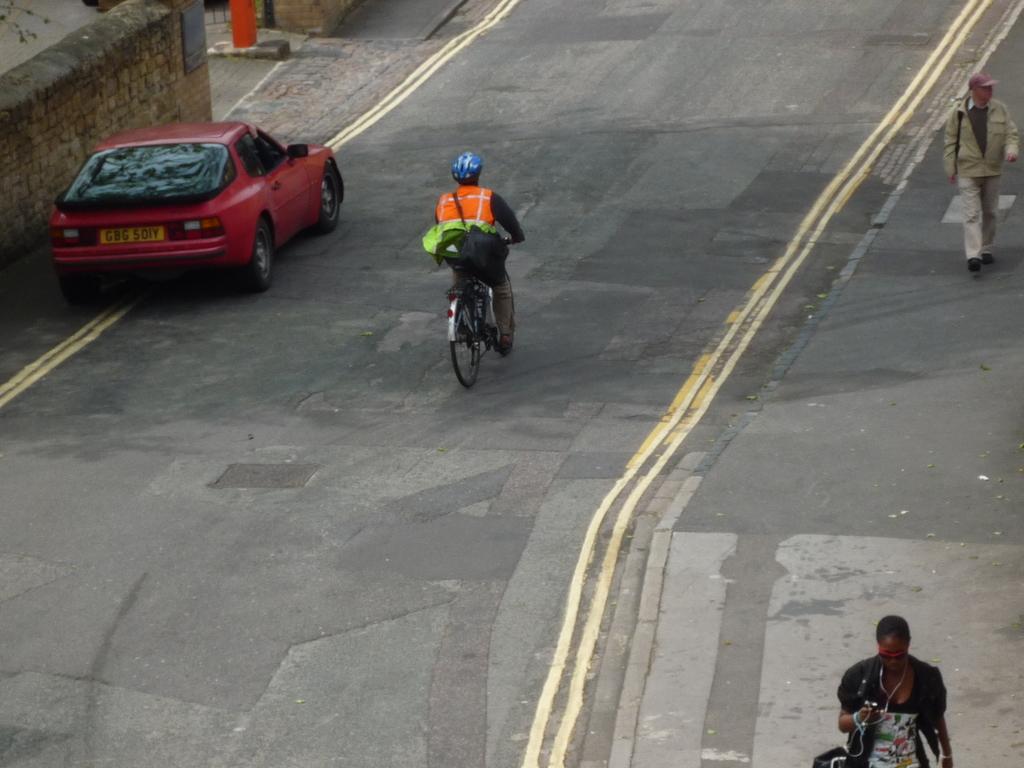Can you describe this image briefly? In the image we can see there is a person who is sitting on a bicycle and a car is parked on the road and people are walking on the footpath. 